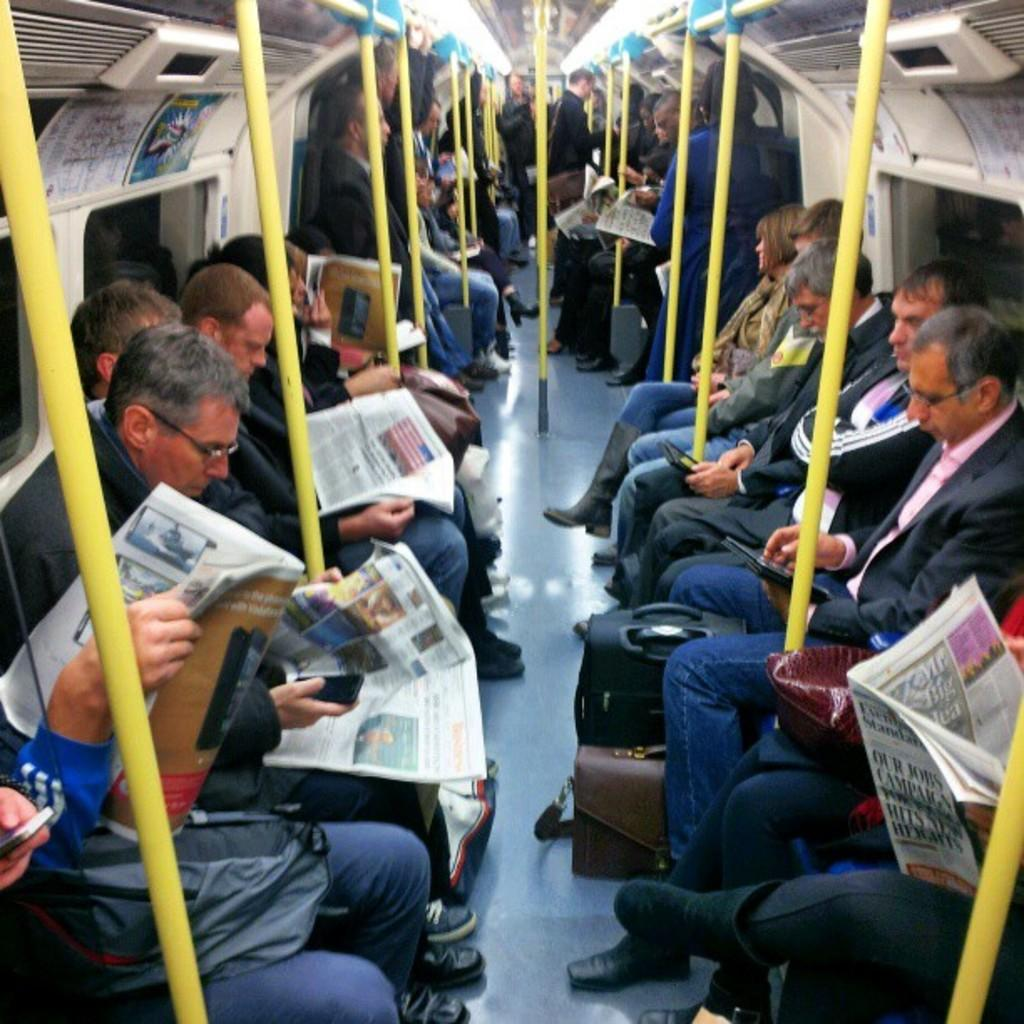What is the main subject of the image? The main subject of the image is a group of men. What are the men doing in the image? The men are sitting in the image. Can you describe the setting of the image? The setting appears to be inside a train. What type of request can be seen written on the wall in the image? There is no request written on the wall in the image. 